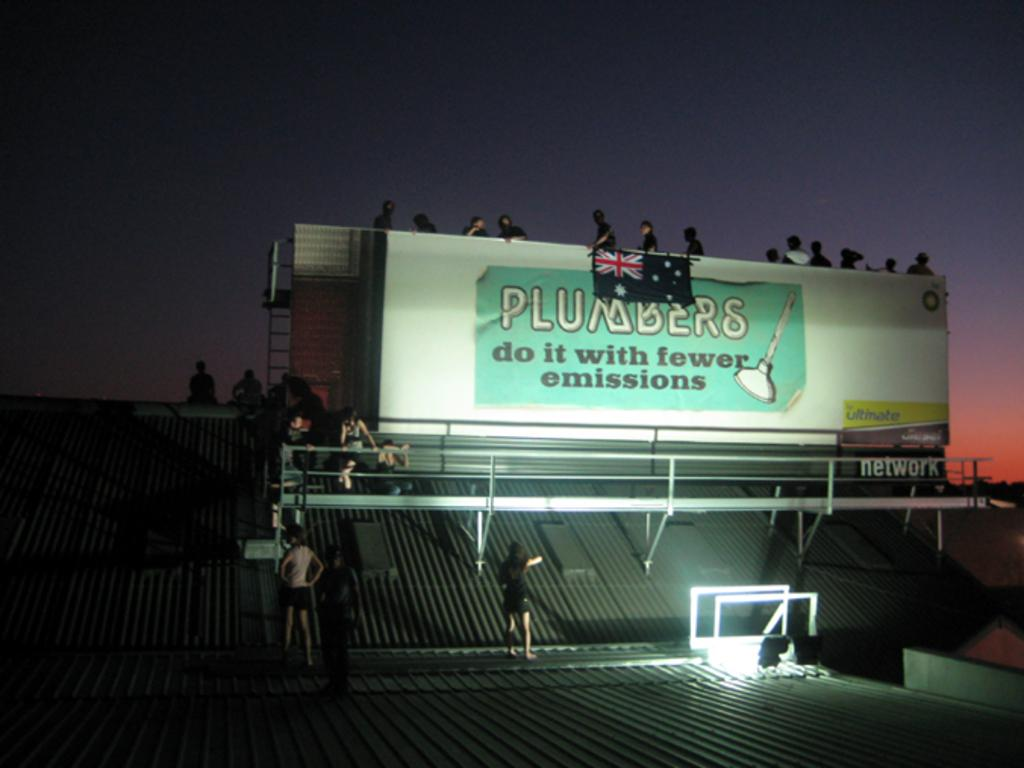Provide a one-sentence caption for the provided image. A billboard says Plumbers do it with fewer emissions on it. 